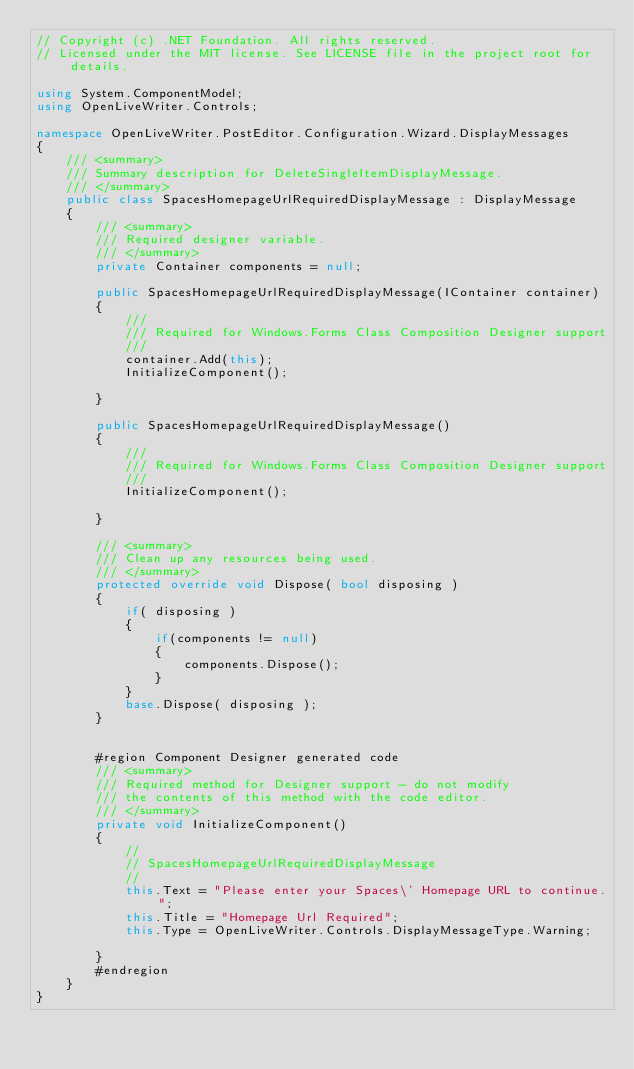<code> <loc_0><loc_0><loc_500><loc_500><_C#_>// Copyright (c) .NET Foundation. All rights reserved.
// Licensed under the MIT license. See LICENSE file in the project root for details.

using System.ComponentModel;
using OpenLiveWriter.Controls;

namespace OpenLiveWriter.PostEditor.Configuration.Wizard.DisplayMessages
{
	/// <summary>
	/// Summary description for DeleteSingleItemDisplayMessage.
	/// </summary>
	public class SpacesHomepageUrlRequiredDisplayMessage : DisplayMessage
	{
		/// <summary>
		/// Required designer variable.
		/// </summary>
		private Container components = null;

		public SpacesHomepageUrlRequiredDisplayMessage(IContainer container)
		{
			///
			/// Required for Windows.Forms Class Composition Designer support
			///
			container.Add(this);
			InitializeComponent();

		}

		public SpacesHomepageUrlRequiredDisplayMessage()
		{
			///
			/// Required for Windows.Forms Class Composition Designer support
			///
			InitializeComponent();

		}

		/// <summary> 
		/// Clean up any resources being used.
		/// </summary>
		protected override void Dispose( bool disposing )
		{
			if( disposing )
			{
				if(components != null)
				{
					components.Dispose();
				}
			}
			base.Dispose( disposing );
		}


		#region Component Designer generated code
		/// <summary>
		/// Required method for Designer support - do not modify
		/// the contents of this method with the code editor.
		/// </summary>
		private void InitializeComponent()
		{
			// 
			// SpacesHomepageUrlRequiredDisplayMessage
			// 
			this.Text = "Please enter your Spaces\' Homepage URL to continue.";
			this.Title = "Homepage Url Required";
			this.Type = OpenLiveWriter.Controls.DisplayMessageType.Warning;

		}
		#endregion
	}
}
</code> 